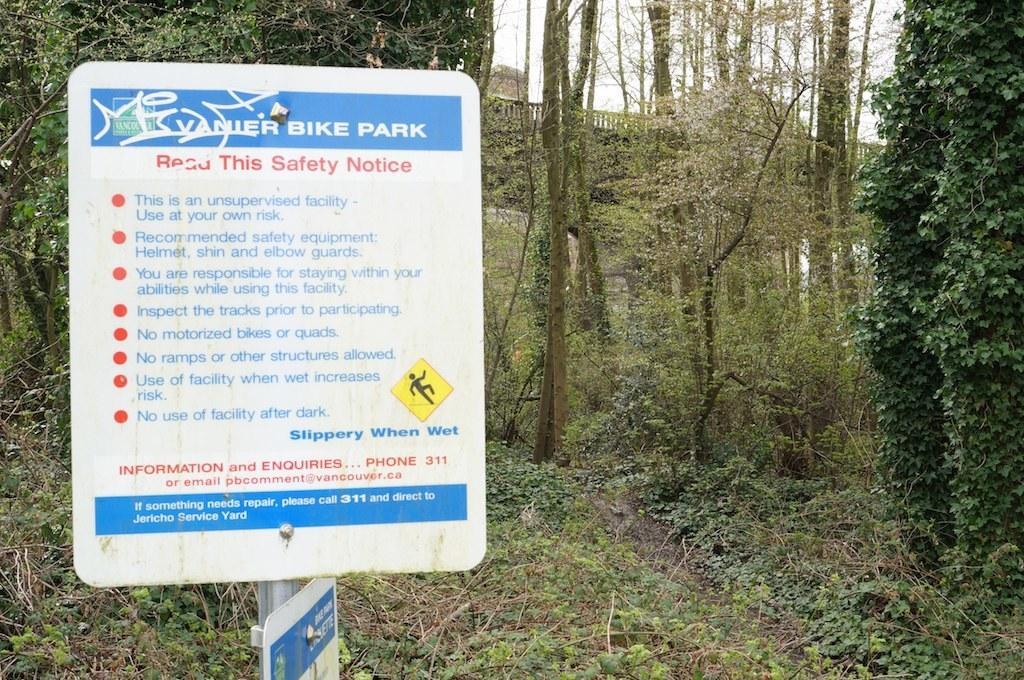Describe this image in one or two sentences. In this image we can see boards on a pole. On the boards there is text and sign. In the back there are trees, plants and creepers. Also there is railing. In the background there is sky. 